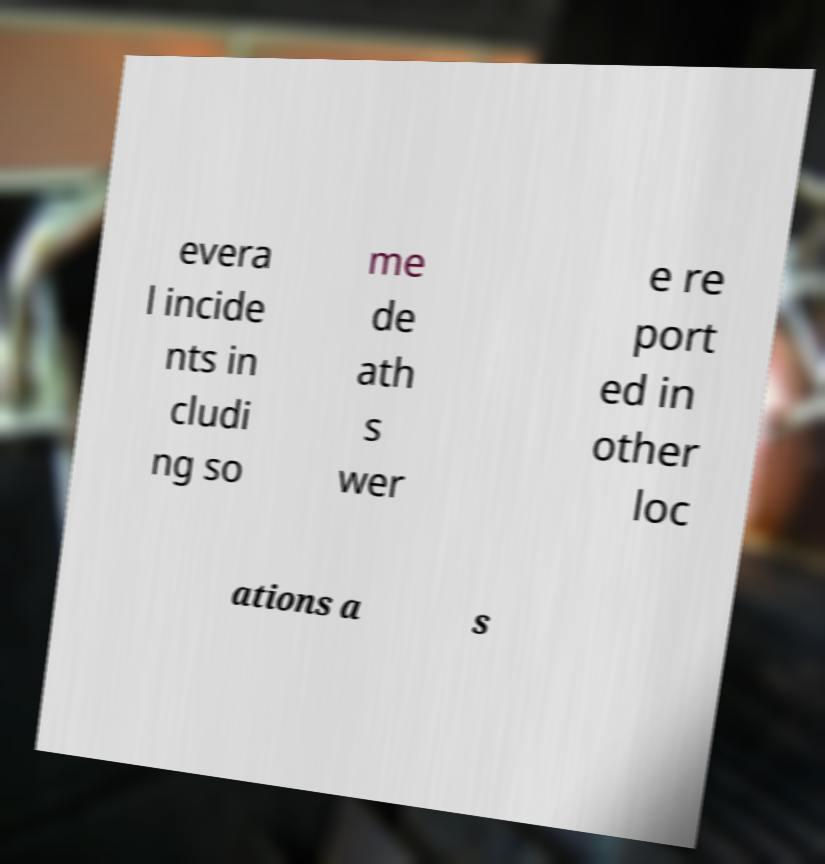Please identify and transcribe the text found in this image. evera l incide nts in cludi ng so me de ath s wer e re port ed in other loc ations a s 